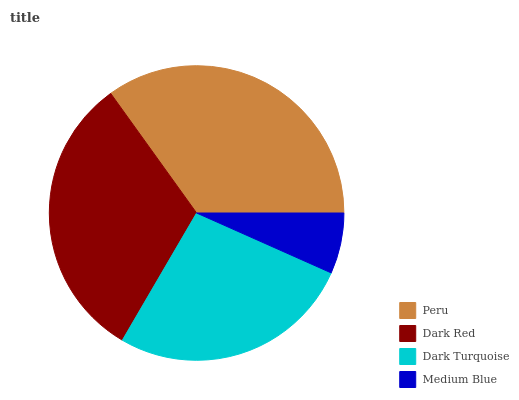Is Medium Blue the minimum?
Answer yes or no. Yes. Is Peru the maximum?
Answer yes or no. Yes. Is Dark Red the minimum?
Answer yes or no. No. Is Dark Red the maximum?
Answer yes or no. No. Is Peru greater than Dark Red?
Answer yes or no. Yes. Is Dark Red less than Peru?
Answer yes or no. Yes. Is Dark Red greater than Peru?
Answer yes or no. No. Is Peru less than Dark Red?
Answer yes or no. No. Is Dark Red the high median?
Answer yes or no. Yes. Is Dark Turquoise the low median?
Answer yes or no. Yes. Is Medium Blue the high median?
Answer yes or no. No. Is Medium Blue the low median?
Answer yes or no. No. 